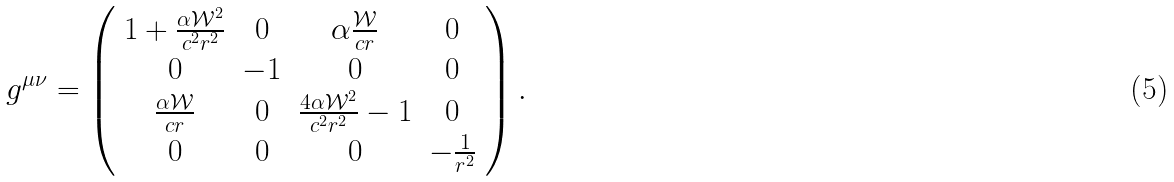<formula> <loc_0><loc_0><loc_500><loc_500>g ^ { \mu \nu } = \left ( \begin{array} { c c c c } 1 + \frac { \alpha \mathcal { W } ^ { 2 } } { c ^ { 2 } r ^ { 2 } } & 0 & \alpha \frac { \mathcal { W } } { c r } & 0 \\ 0 & - 1 & 0 & 0 \\ \frac { \alpha \mathcal { W } } { c r } & 0 & \frac { 4 \alpha \mathcal { W } ^ { 2 } } { c ^ { 2 } r ^ { 2 } } - 1 & 0 \\ 0 & 0 & 0 & - \frac { 1 } { r ^ { 2 } } \end{array} \right ) .</formula> 